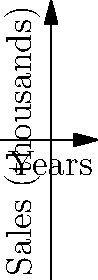The graph shows the sales trends of three clarinet brands over five years. Which brand shows the most consistent growth throughout the period, and what could this imply for a professional clarinet player considering a long-term investment? To answer this question, we need to analyze the behavior of each brand's sales curve:

1. Brand A (blue curve):
   - Starts high but decreases initially
   - Shows rapid growth in later years
   - Exhibits volatile behavior

2. Brand B (red curve):
   - Starts highest but shows a steady decline
   - Ends with the lowest sales

3. Brand C (green curve):
   - Starts lower than the others
   - Shows steady, consistent growth throughout the period
   - Ends with the highest sales

Brand C demonstrates the most consistent growth over the five-year period. Its sales curve is smoother and steadily increasing, without the volatility seen in Brand A or the decline of Brand B.

For a professional clarinet player considering a long-term investment:

1. Consistent growth suggests Brand C is gaining popularity and market share.
2. Steady increase might indicate improving quality or effective marketing.
3. Long-term stability is crucial for professionals who need reliable instruments and parts availability.
4. Growing popularity could lead to more resources for product development and support.

Therefore, Brand C appears to be the most promising option for a long-term investment in a professional clarinet.
Answer: Brand C shows the most consistent growth, implying it could be the best long-term investment for a professional clarinet player. 